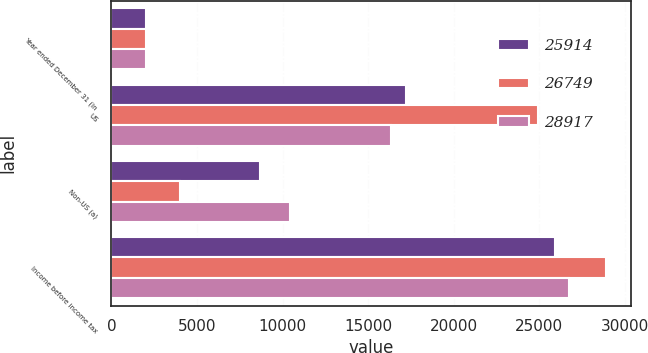Convert chart. <chart><loc_0><loc_0><loc_500><loc_500><stacked_bar_chart><ecel><fcel>Year ended December 31 (in<fcel>US<fcel>Non-US (a)<fcel>Income before income tax<nl><fcel>25914<fcel>2013<fcel>17229<fcel>8685<fcel>25914<nl><fcel>26749<fcel>2012<fcel>24895<fcel>4022<fcel>28917<nl><fcel>28917<fcel>2011<fcel>16336<fcel>10413<fcel>26749<nl></chart> 